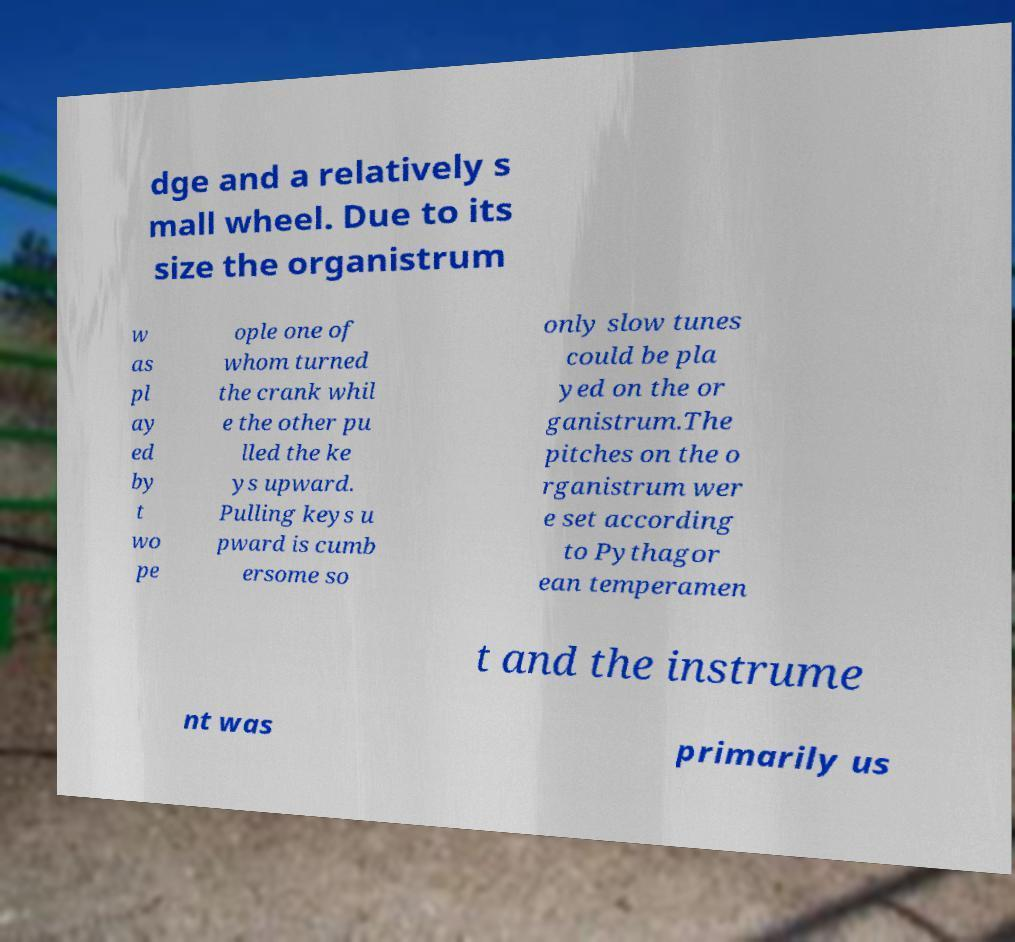Please read and relay the text visible in this image. What does it say? dge and a relatively s mall wheel. Due to its size the organistrum w as pl ay ed by t wo pe ople one of whom turned the crank whil e the other pu lled the ke ys upward. Pulling keys u pward is cumb ersome so only slow tunes could be pla yed on the or ganistrum.The pitches on the o rganistrum wer e set according to Pythagor ean temperamen t and the instrume nt was primarily us 